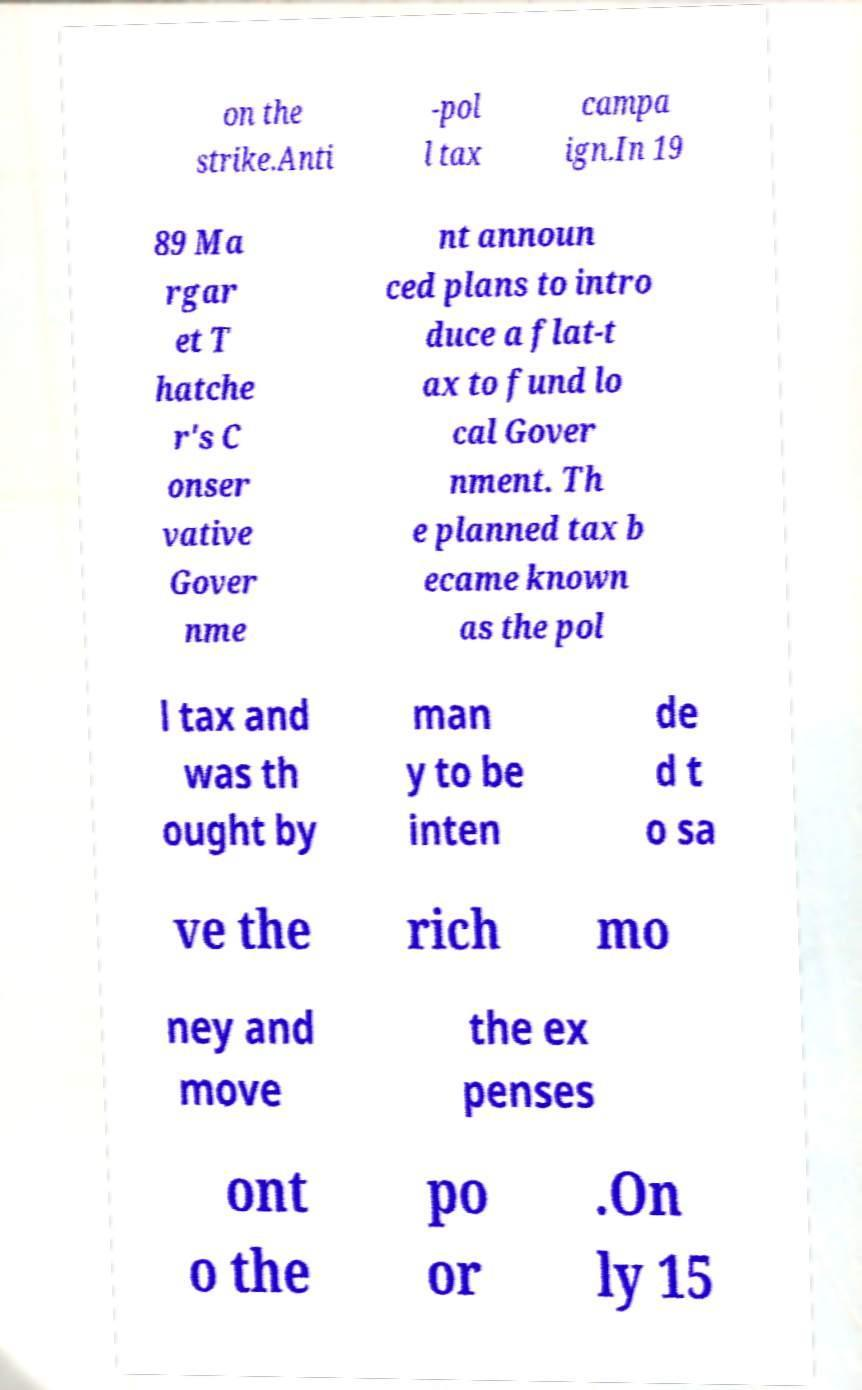What messages or text are displayed in this image? I need them in a readable, typed format. on the strike.Anti -pol l tax campa ign.In 19 89 Ma rgar et T hatche r's C onser vative Gover nme nt announ ced plans to intro duce a flat-t ax to fund lo cal Gover nment. Th e planned tax b ecame known as the pol l tax and was th ought by man y to be inten de d t o sa ve the rich mo ney and move the ex penses ont o the po or .On ly 15 